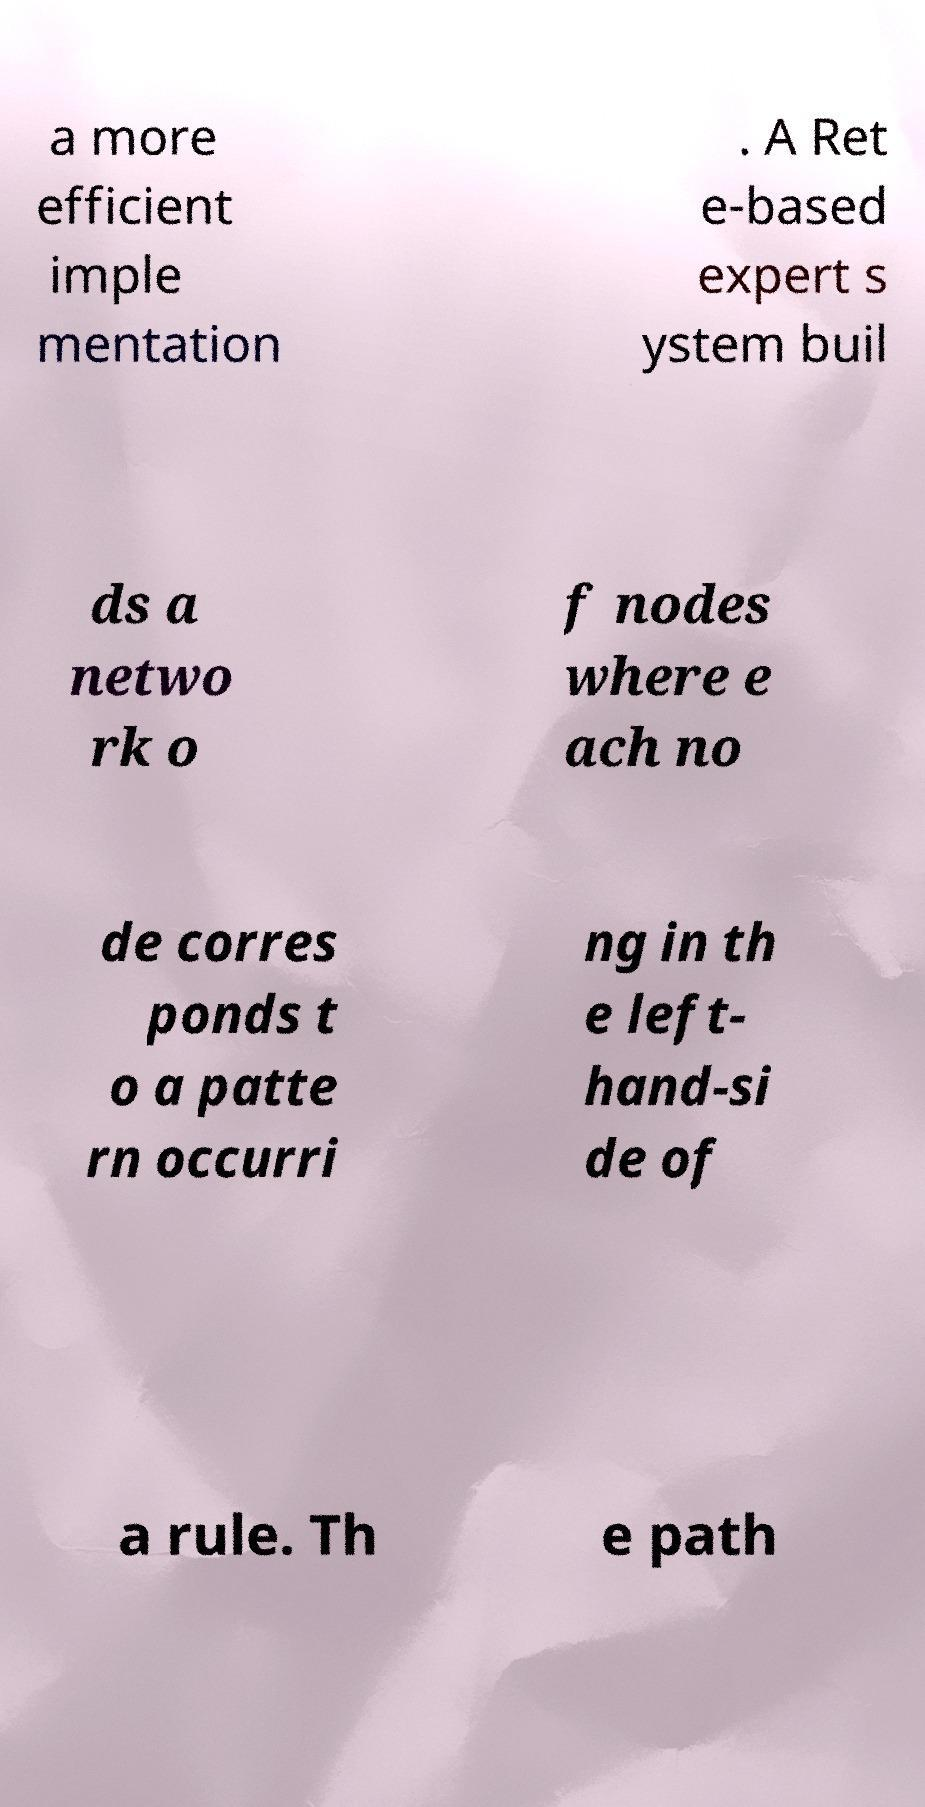For documentation purposes, I need the text within this image transcribed. Could you provide that? a more efficient imple mentation . A Ret e-based expert s ystem buil ds a netwo rk o f nodes where e ach no de corres ponds t o a patte rn occurri ng in th e left- hand-si de of a rule. Th e path 